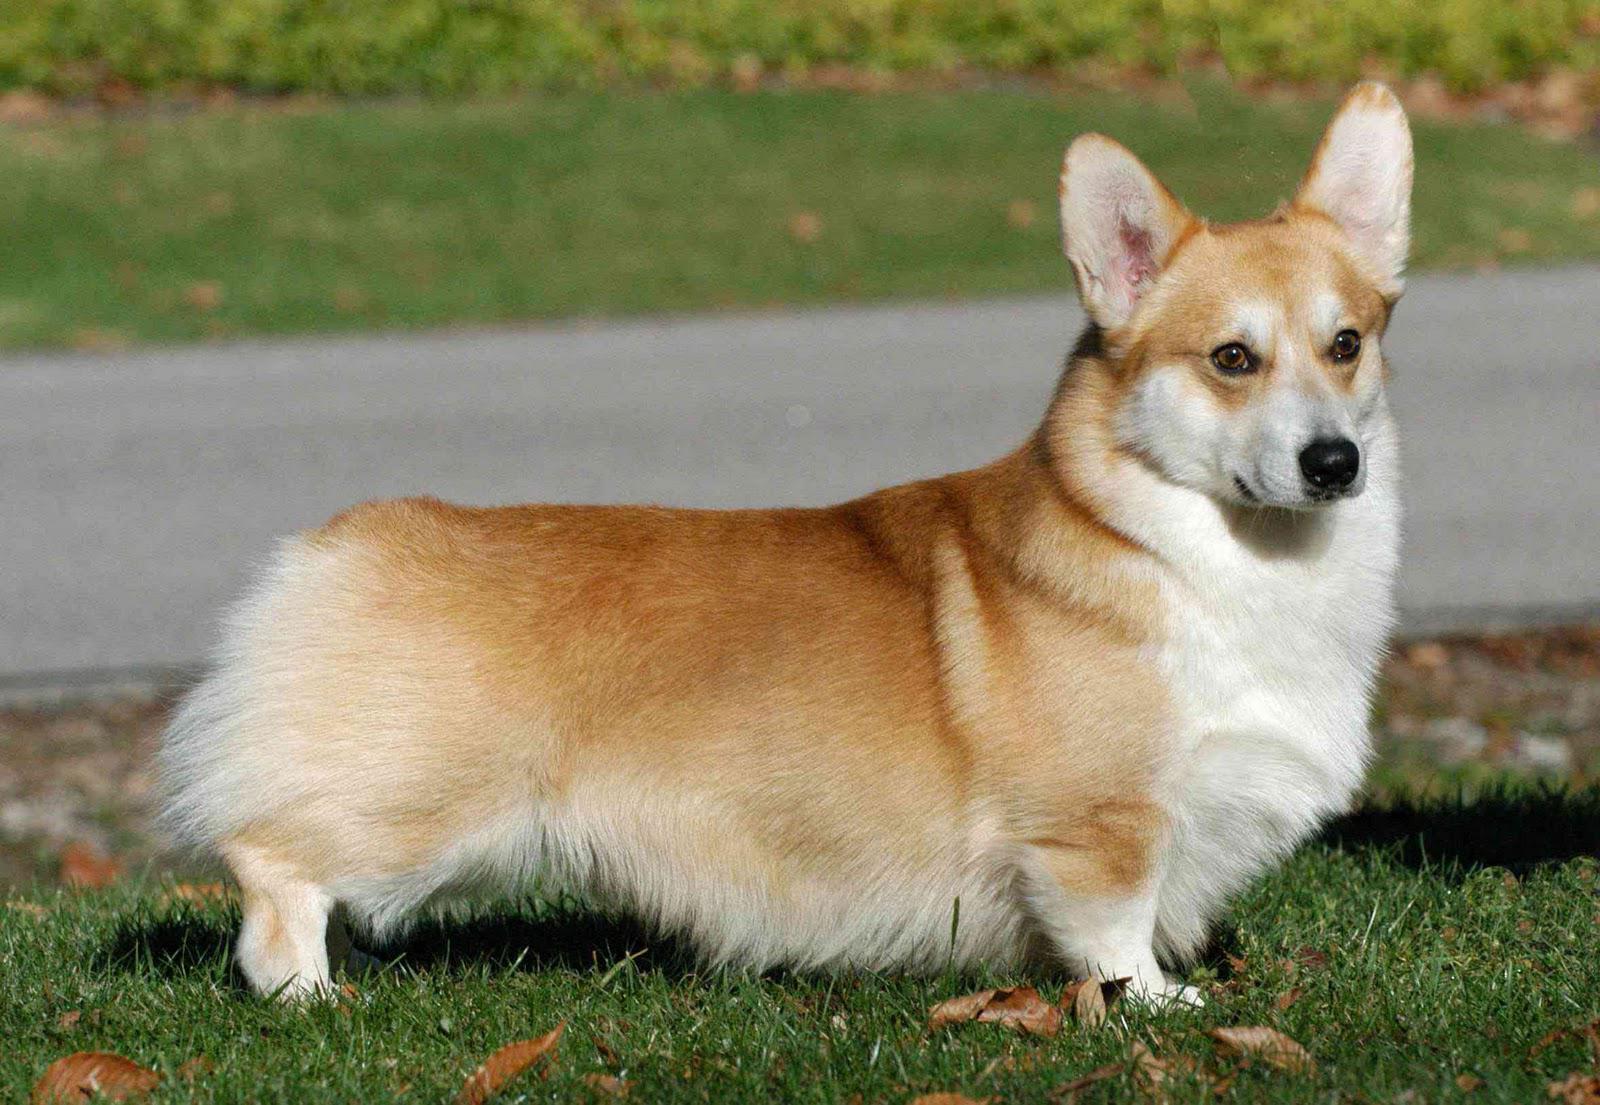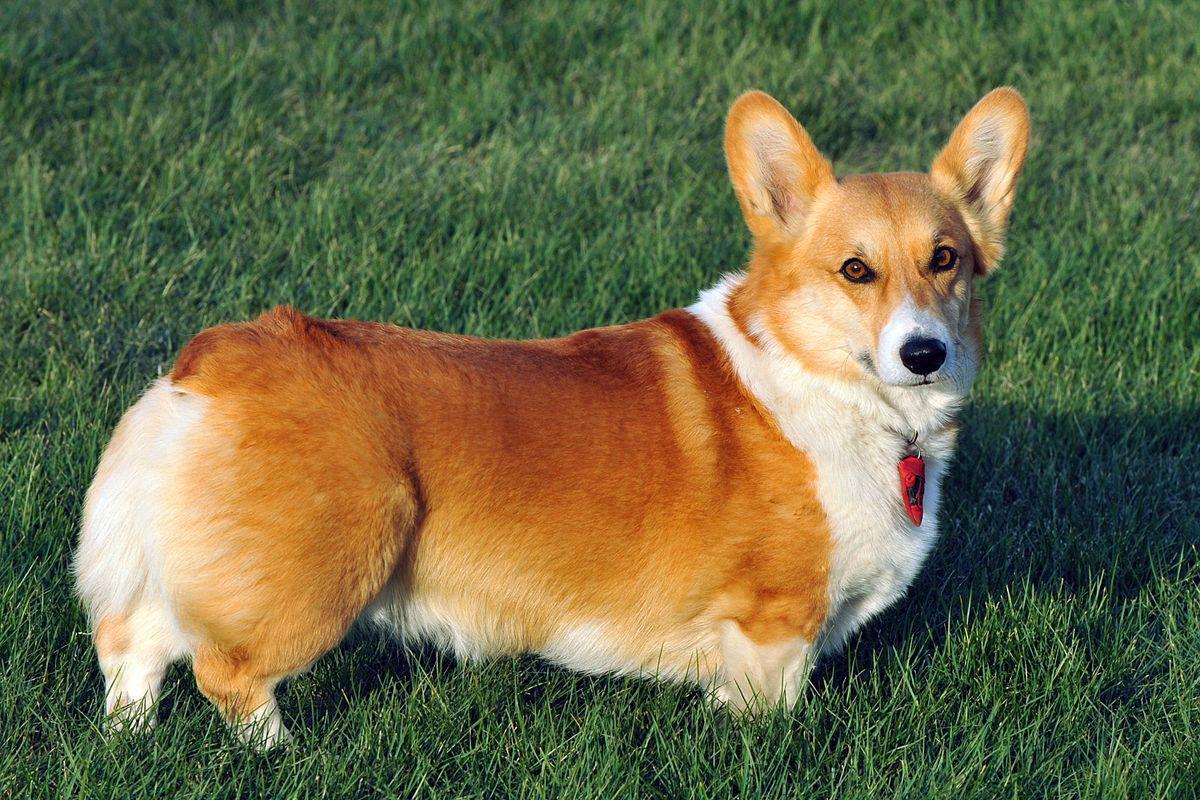The first image is the image on the left, the second image is the image on the right. Given the left and right images, does the statement "The dogs in the images are in profile, with one body turned to the right and the other to the left." hold true? Answer yes or no. No. 